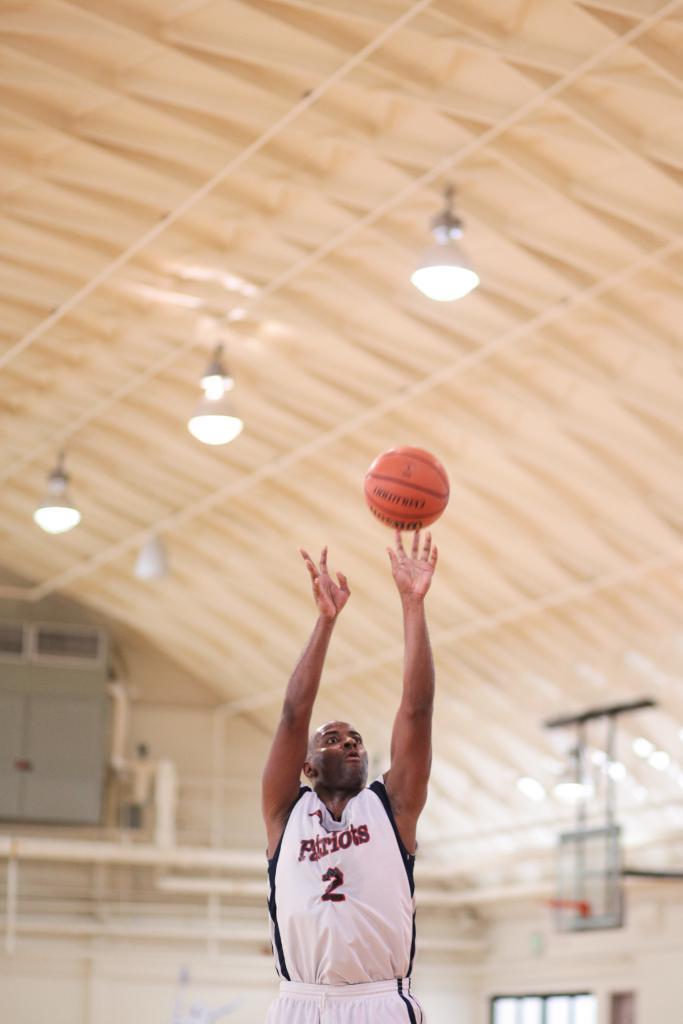Can you describe this image briefly? In this image we can see a man standing on the floor and a ball. In the background we can see cupboards, shed and electric lights. 